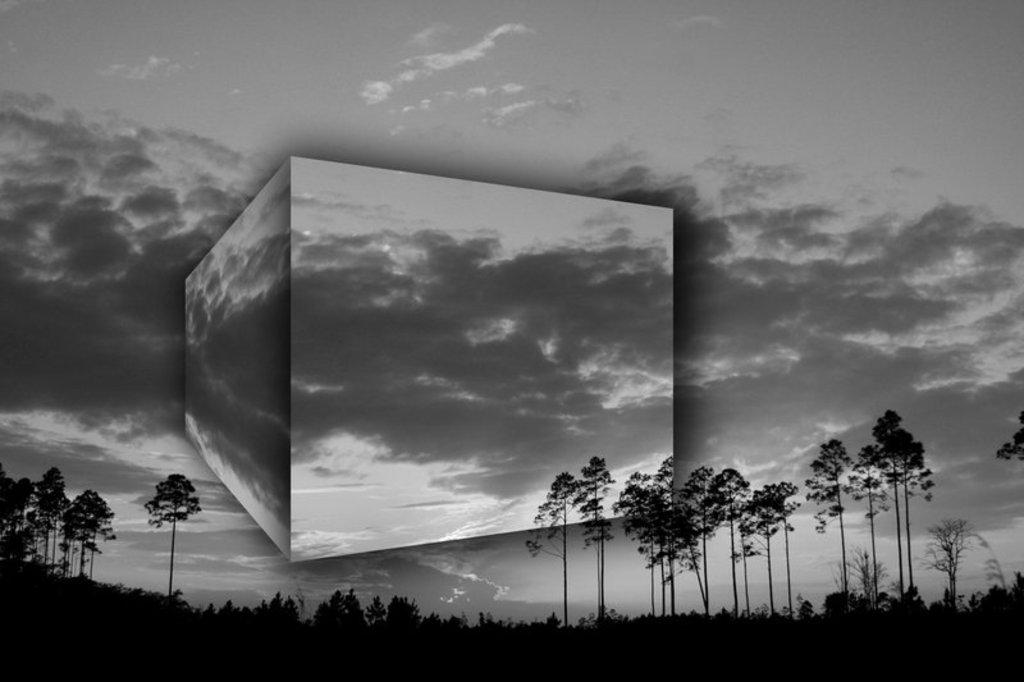What type of vegetation can be seen in the image? There are plants and trees in the image. What is the condition of the sky in the image? The sky is clear in the image. Can you tell me which actor is performing in the image? There are no actors or performances present in the image; it features plants, trees, and a clear sky. What is the end result of the stomach's digestion process in the image? There is no stomach or digestion process present in the image; it focuses on vegetation and the sky. 